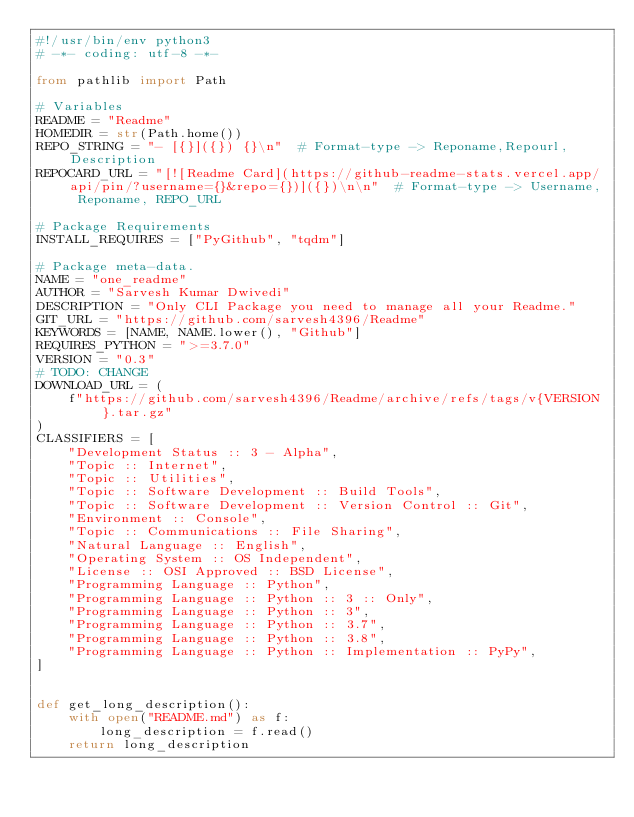Convert code to text. <code><loc_0><loc_0><loc_500><loc_500><_Python_>#!/usr/bin/env python3
# -*- coding: utf-8 -*-

from pathlib import Path

# Variables
README = "Readme"
HOMEDIR = str(Path.home())
REPO_STRING = "- [{}]({}) {}\n"  # Format-type -> Reponame,Repourl,Description
REPOCARD_URL = "[![Readme Card](https://github-readme-stats.vercel.app/api/pin/?username={}&repo={})]({})\n\n"  # Format-type -> Username, Reponame, REPO_URL

# Package Requirements
INSTALL_REQUIRES = ["PyGithub", "tqdm"]

# Package meta-data.
NAME = "one_readme"
AUTHOR = "Sarvesh Kumar Dwivedi"
DESCRIPTION = "Only CLI Package you need to manage all your Readme."
GIT_URL = "https://github.com/sarvesh4396/Readme"
KEYWORDS = [NAME, NAME.lower(), "Github"]
REQUIRES_PYTHON = ">=3.7.0"
VERSION = "0.3"
# TODO: CHANGE
DOWNLOAD_URL = (
    f"https://github.com/sarvesh4396/Readme/archive/refs/tags/v{VERSION}.tar.gz"
)
CLASSIFIERS = [
    "Development Status :: 3 - Alpha",
    "Topic :: Internet",
    "Topic :: Utilities",
    "Topic :: Software Development :: Build Tools",
    "Topic :: Software Development :: Version Control :: Git",
    "Environment :: Console",
    "Topic :: Communications :: File Sharing",
    "Natural Language :: English",
    "Operating System :: OS Independent",
    "License :: OSI Approved :: BSD License",
    "Programming Language :: Python",
    "Programming Language :: Python :: 3 :: Only",
    "Programming Language :: Python :: 3",
    "Programming Language :: Python :: 3.7",
    "Programming Language :: Python :: 3.8",
    "Programming Language :: Python :: Implementation :: PyPy",
]


def get_long_description():
    with open("README.md") as f:
        long_description = f.read()
    return long_description
</code> 